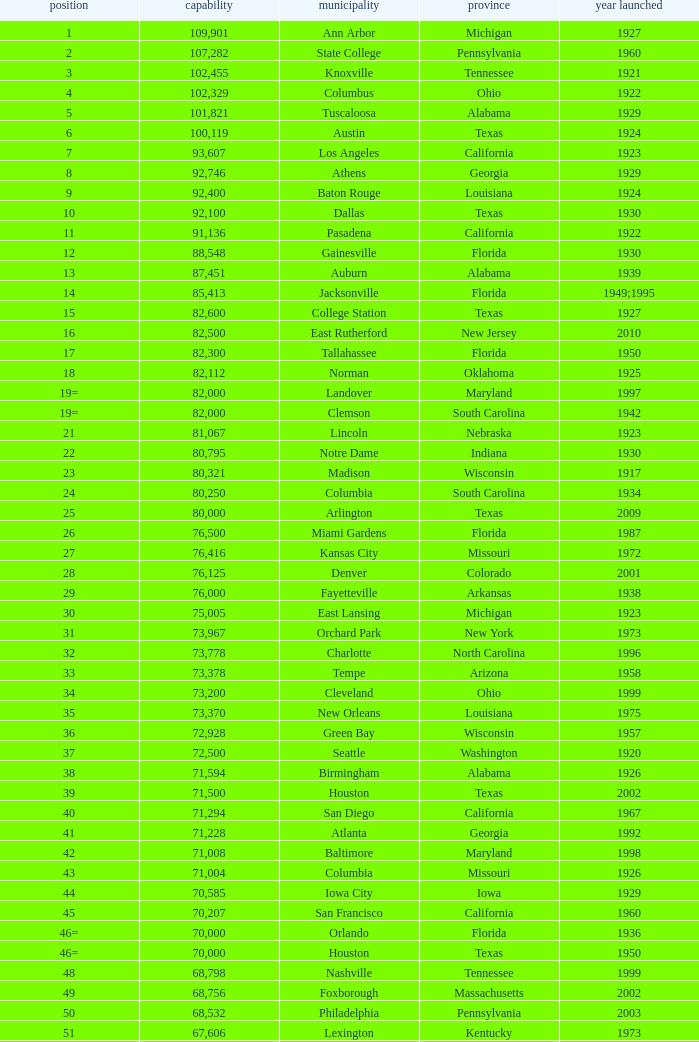What is the rank for the year opened in 1959 in Pennsylvania? 134=. 